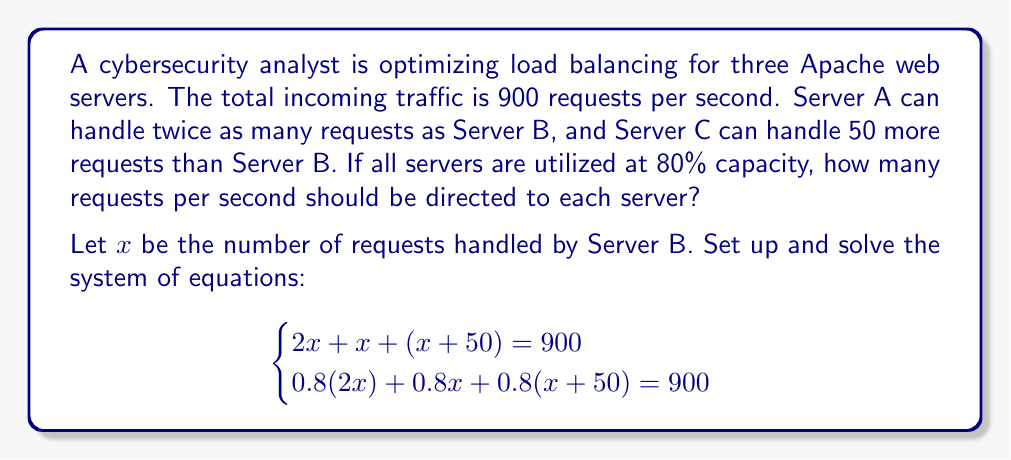Can you solve this math problem? Let's solve this system of equations step by step:

1) From the first equation:
   $2x + x + (x + 50) = 900$
   $4x + 50 = 900$
   $4x = 850$
   $x = 212.5$

2) Let's verify this solution using the second equation:
   $0.8(2x) + 0.8x + 0.8(x + 50) = 900$
   $1.6x + 0.8x + 0.8x + 40 = 900$
   $3.2x + 40 = 900$
   $3.2x = 860$
   $x = 268.75$

3) The solutions don't match, so we need to solve the system simultaneously:

4) Simplify the equations:
   Equation 1: $4x + 50 = 900$
   Equation 2: $3.2x + 40 = 900$

5) Subtract Equation 2 from Equation 1:
   $0.8x + 10 = 0$
   $0.8x = -10$
   $x = -12.5$

6) This negative value doesn't make sense in our context. Let's revisit our original equations and adjust for the 80% utilization:

   $0.8(2x) + 0.8x + 0.8(x + 50) = 900$
   $1.6x + 0.8x + 0.8x + 40 = 900$
   $3.2x + 40 = 900$
   $3.2x = 860$
   $x = 268.75$

7) Now we can calculate the requests for each server:
   Server A: $2x = 2(268.75) = 537.5$
   Server B: $x = 268.75$
   Server C: $x + 50 = 268.75 + 50 = 318.75$

8) Verify: $537.5 + 268.75 + 318.75 = 1125$
   At 80% capacity: $1125 * 0.8 = 900$, which matches our total incoming traffic.
Answer: Server A: 538 req/s, Server B: 269 req/s, Server C: 319 req/s 